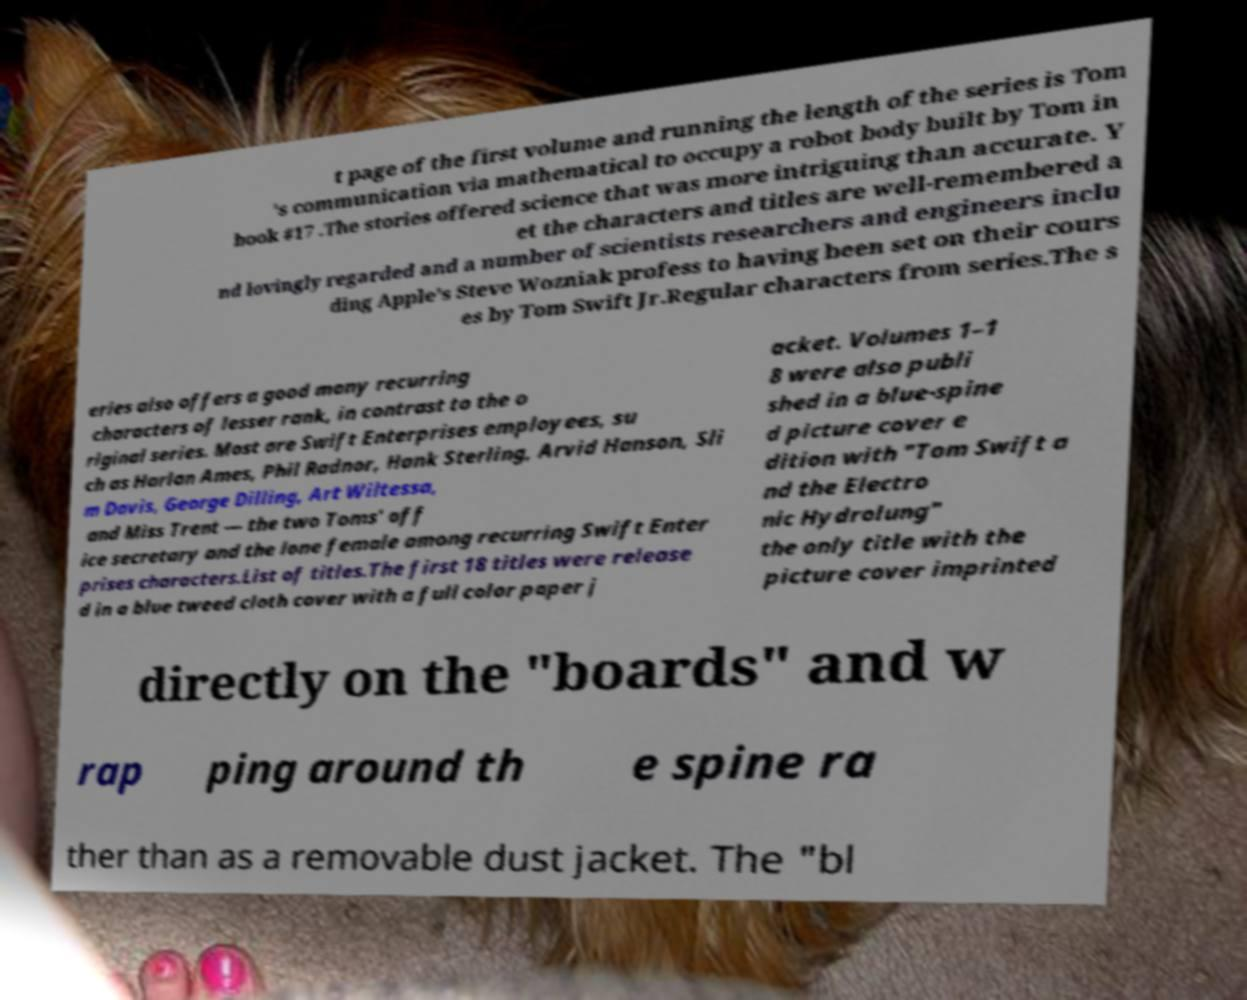Please identify and transcribe the text found in this image. t page of the first volume and running the length of the series is Tom 's communication via mathematical to occupy a robot body built by Tom in book #17 .The stories offered science that was more intriguing than accurate. Y et the characters and titles are well-remembered a nd lovingly regarded and a number of scientists researchers and engineers inclu ding Apple's Steve Wozniak profess to having been set on their cours es by Tom Swift Jr.Regular characters from series.The s eries also offers a good many recurring characters of lesser rank, in contrast to the o riginal series. Most are Swift Enterprises employees, su ch as Harlan Ames, Phil Radnor, Hank Sterling, Arvid Hanson, Sli m Davis, George Dilling, Art Wiltessa, and Miss Trent — the two Toms' off ice secretary and the lone female among recurring Swift Enter prises characters.List of titles.The first 18 titles were release d in a blue tweed cloth cover with a full color paper j acket. Volumes 1–1 8 were also publi shed in a blue-spine d picture cover e dition with "Tom Swift a nd the Electro nic Hydrolung" the only title with the picture cover imprinted directly on the "boards" and w rap ping around th e spine ra ther than as a removable dust jacket. The "bl 